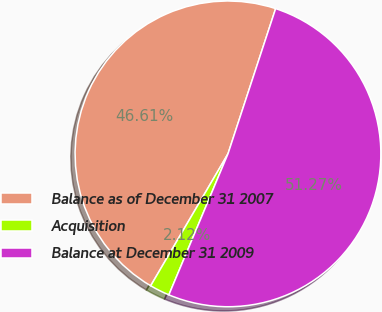Convert chart to OTSL. <chart><loc_0><loc_0><loc_500><loc_500><pie_chart><fcel>Balance as of December 31 2007<fcel>Acquisition<fcel>Balance at December 31 2009<nl><fcel>46.61%<fcel>2.12%<fcel>51.27%<nl></chart> 